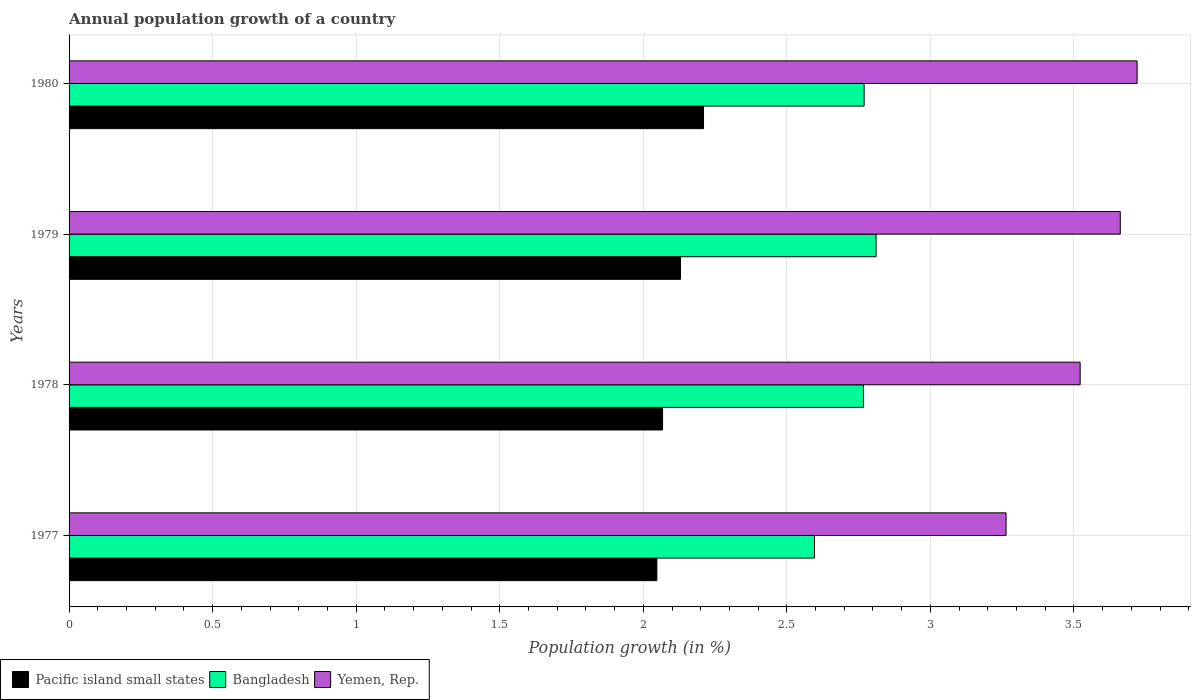How many groups of bars are there?
Offer a terse response. 4. What is the label of the 3rd group of bars from the top?
Your answer should be very brief. 1978. In how many cases, is the number of bars for a given year not equal to the number of legend labels?
Offer a very short reply. 0. What is the annual population growth in Bangladesh in 1980?
Your response must be concise. 2.77. Across all years, what is the maximum annual population growth in Yemen, Rep.?
Your answer should be very brief. 3.72. Across all years, what is the minimum annual population growth in Bangladesh?
Offer a very short reply. 2.6. What is the total annual population growth in Yemen, Rep. in the graph?
Make the answer very short. 14.17. What is the difference between the annual population growth in Bangladesh in 1977 and that in 1978?
Keep it short and to the point. -0.17. What is the difference between the annual population growth in Bangladesh in 1979 and the annual population growth in Pacific island small states in 1978?
Provide a short and direct response. 0.74. What is the average annual population growth in Pacific island small states per year?
Keep it short and to the point. 2.11. In the year 1980, what is the difference between the annual population growth in Pacific island small states and annual population growth in Bangladesh?
Give a very brief answer. -0.56. What is the ratio of the annual population growth in Bangladesh in 1978 to that in 1980?
Your response must be concise. 1. Is the annual population growth in Bangladesh in 1979 less than that in 1980?
Provide a short and direct response. No. Is the difference between the annual population growth in Pacific island small states in 1977 and 1978 greater than the difference between the annual population growth in Bangladesh in 1977 and 1978?
Keep it short and to the point. Yes. What is the difference between the highest and the second highest annual population growth in Bangladesh?
Your answer should be compact. 0.04. What is the difference between the highest and the lowest annual population growth in Yemen, Rep.?
Keep it short and to the point. 0.46. What does the 3rd bar from the top in 1977 represents?
Make the answer very short. Pacific island small states. What does the 3rd bar from the bottom in 1979 represents?
Your answer should be compact. Yemen, Rep. Is it the case that in every year, the sum of the annual population growth in Yemen, Rep. and annual population growth in Pacific island small states is greater than the annual population growth in Bangladesh?
Your response must be concise. Yes. How many bars are there?
Provide a succinct answer. 12. What is the difference between two consecutive major ticks on the X-axis?
Your answer should be compact. 0.5. Are the values on the major ticks of X-axis written in scientific E-notation?
Your answer should be very brief. No. Does the graph contain any zero values?
Offer a very short reply. No. Does the graph contain grids?
Your answer should be very brief. Yes. Where does the legend appear in the graph?
Make the answer very short. Bottom left. How many legend labels are there?
Your answer should be very brief. 3. What is the title of the graph?
Keep it short and to the point. Annual population growth of a country. What is the label or title of the X-axis?
Your answer should be very brief. Population growth (in %). What is the label or title of the Y-axis?
Provide a short and direct response. Years. What is the Population growth (in %) in Pacific island small states in 1977?
Ensure brevity in your answer.  2.05. What is the Population growth (in %) in Bangladesh in 1977?
Offer a very short reply. 2.6. What is the Population growth (in %) of Yemen, Rep. in 1977?
Your response must be concise. 3.26. What is the Population growth (in %) of Pacific island small states in 1978?
Offer a terse response. 2.07. What is the Population growth (in %) of Bangladesh in 1978?
Give a very brief answer. 2.77. What is the Population growth (in %) in Yemen, Rep. in 1978?
Offer a very short reply. 3.52. What is the Population growth (in %) of Pacific island small states in 1979?
Your answer should be very brief. 2.13. What is the Population growth (in %) in Bangladesh in 1979?
Offer a very short reply. 2.81. What is the Population growth (in %) in Yemen, Rep. in 1979?
Keep it short and to the point. 3.66. What is the Population growth (in %) of Pacific island small states in 1980?
Provide a short and direct response. 2.21. What is the Population growth (in %) in Bangladesh in 1980?
Keep it short and to the point. 2.77. What is the Population growth (in %) in Yemen, Rep. in 1980?
Ensure brevity in your answer.  3.72. Across all years, what is the maximum Population growth (in %) in Pacific island small states?
Your answer should be very brief. 2.21. Across all years, what is the maximum Population growth (in %) of Bangladesh?
Ensure brevity in your answer.  2.81. Across all years, what is the maximum Population growth (in %) of Yemen, Rep.?
Keep it short and to the point. 3.72. Across all years, what is the minimum Population growth (in %) of Pacific island small states?
Ensure brevity in your answer.  2.05. Across all years, what is the minimum Population growth (in %) of Bangladesh?
Keep it short and to the point. 2.6. Across all years, what is the minimum Population growth (in %) of Yemen, Rep.?
Provide a succinct answer. 3.26. What is the total Population growth (in %) in Pacific island small states in the graph?
Provide a succinct answer. 8.45. What is the total Population growth (in %) of Bangladesh in the graph?
Ensure brevity in your answer.  10.94. What is the total Population growth (in %) in Yemen, Rep. in the graph?
Provide a succinct answer. 14.17. What is the difference between the Population growth (in %) of Pacific island small states in 1977 and that in 1978?
Offer a very short reply. -0.02. What is the difference between the Population growth (in %) in Bangladesh in 1977 and that in 1978?
Offer a very short reply. -0.17. What is the difference between the Population growth (in %) in Yemen, Rep. in 1977 and that in 1978?
Your response must be concise. -0.26. What is the difference between the Population growth (in %) in Pacific island small states in 1977 and that in 1979?
Keep it short and to the point. -0.08. What is the difference between the Population growth (in %) in Bangladesh in 1977 and that in 1979?
Your answer should be compact. -0.21. What is the difference between the Population growth (in %) in Yemen, Rep. in 1977 and that in 1979?
Make the answer very short. -0.4. What is the difference between the Population growth (in %) in Pacific island small states in 1977 and that in 1980?
Ensure brevity in your answer.  -0.16. What is the difference between the Population growth (in %) in Bangladesh in 1977 and that in 1980?
Provide a short and direct response. -0.17. What is the difference between the Population growth (in %) of Yemen, Rep. in 1977 and that in 1980?
Your answer should be very brief. -0.46. What is the difference between the Population growth (in %) in Pacific island small states in 1978 and that in 1979?
Provide a succinct answer. -0.06. What is the difference between the Population growth (in %) of Bangladesh in 1978 and that in 1979?
Give a very brief answer. -0.04. What is the difference between the Population growth (in %) of Yemen, Rep. in 1978 and that in 1979?
Offer a terse response. -0.14. What is the difference between the Population growth (in %) of Pacific island small states in 1978 and that in 1980?
Offer a very short reply. -0.14. What is the difference between the Population growth (in %) of Bangladesh in 1978 and that in 1980?
Keep it short and to the point. -0. What is the difference between the Population growth (in %) in Yemen, Rep. in 1978 and that in 1980?
Provide a succinct answer. -0.2. What is the difference between the Population growth (in %) in Pacific island small states in 1979 and that in 1980?
Your response must be concise. -0.08. What is the difference between the Population growth (in %) of Bangladesh in 1979 and that in 1980?
Keep it short and to the point. 0.04. What is the difference between the Population growth (in %) in Yemen, Rep. in 1979 and that in 1980?
Keep it short and to the point. -0.06. What is the difference between the Population growth (in %) in Pacific island small states in 1977 and the Population growth (in %) in Bangladesh in 1978?
Provide a succinct answer. -0.72. What is the difference between the Population growth (in %) of Pacific island small states in 1977 and the Population growth (in %) of Yemen, Rep. in 1978?
Offer a very short reply. -1.47. What is the difference between the Population growth (in %) in Bangladesh in 1977 and the Population growth (in %) in Yemen, Rep. in 1978?
Keep it short and to the point. -0.93. What is the difference between the Population growth (in %) of Pacific island small states in 1977 and the Population growth (in %) of Bangladesh in 1979?
Give a very brief answer. -0.76. What is the difference between the Population growth (in %) of Pacific island small states in 1977 and the Population growth (in %) of Yemen, Rep. in 1979?
Your answer should be very brief. -1.61. What is the difference between the Population growth (in %) in Bangladesh in 1977 and the Population growth (in %) in Yemen, Rep. in 1979?
Your answer should be compact. -1.07. What is the difference between the Population growth (in %) of Pacific island small states in 1977 and the Population growth (in %) of Bangladesh in 1980?
Give a very brief answer. -0.72. What is the difference between the Population growth (in %) of Pacific island small states in 1977 and the Population growth (in %) of Yemen, Rep. in 1980?
Provide a succinct answer. -1.67. What is the difference between the Population growth (in %) in Bangladesh in 1977 and the Population growth (in %) in Yemen, Rep. in 1980?
Keep it short and to the point. -1.12. What is the difference between the Population growth (in %) in Pacific island small states in 1978 and the Population growth (in %) in Bangladesh in 1979?
Offer a terse response. -0.74. What is the difference between the Population growth (in %) in Pacific island small states in 1978 and the Population growth (in %) in Yemen, Rep. in 1979?
Give a very brief answer. -1.59. What is the difference between the Population growth (in %) in Bangladesh in 1978 and the Population growth (in %) in Yemen, Rep. in 1979?
Provide a succinct answer. -0.89. What is the difference between the Population growth (in %) of Pacific island small states in 1978 and the Population growth (in %) of Bangladesh in 1980?
Make the answer very short. -0.7. What is the difference between the Population growth (in %) in Pacific island small states in 1978 and the Population growth (in %) in Yemen, Rep. in 1980?
Offer a terse response. -1.65. What is the difference between the Population growth (in %) of Bangladesh in 1978 and the Population growth (in %) of Yemen, Rep. in 1980?
Your answer should be compact. -0.95. What is the difference between the Population growth (in %) in Pacific island small states in 1979 and the Population growth (in %) in Bangladesh in 1980?
Provide a short and direct response. -0.64. What is the difference between the Population growth (in %) in Pacific island small states in 1979 and the Population growth (in %) in Yemen, Rep. in 1980?
Provide a short and direct response. -1.59. What is the difference between the Population growth (in %) of Bangladesh in 1979 and the Population growth (in %) of Yemen, Rep. in 1980?
Your answer should be very brief. -0.91. What is the average Population growth (in %) in Pacific island small states per year?
Make the answer very short. 2.11. What is the average Population growth (in %) in Bangladesh per year?
Ensure brevity in your answer.  2.74. What is the average Population growth (in %) in Yemen, Rep. per year?
Give a very brief answer. 3.54. In the year 1977, what is the difference between the Population growth (in %) in Pacific island small states and Population growth (in %) in Bangladesh?
Your answer should be very brief. -0.55. In the year 1977, what is the difference between the Population growth (in %) of Pacific island small states and Population growth (in %) of Yemen, Rep.?
Your answer should be very brief. -1.22. In the year 1977, what is the difference between the Population growth (in %) of Bangladesh and Population growth (in %) of Yemen, Rep.?
Your answer should be compact. -0.67. In the year 1978, what is the difference between the Population growth (in %) of Pacific island small states and Population growth (in %) of Bangladesh?
Give a very brief answer. -0.7. In the year 1978, what is the difference between the Population growth (in %) of Pacific island small states and Population growth (in %) of Yemen, Rep.?
Offer a very short reply. -1.45. In the year 1978, what is the difference between the Population growth (in %) of Bangladesh and Population growth (in %) of Yemen, Rep.?
Your response must be concise. -0.75. In the year 1979, what is the difference between the Population growth (in %) of Pacific island small states and Population growth (in %) of Bangladesh?
Offer a very short reply. -0.68. In the year 1979, what is the difference between the Population growth (in %) of Pacific island small states and Population growth (in %) of Yemen, Rep.?
Make the answer very short. -1.53. In the year 1979, what is the difference between the Population growth (in %) in Bangladesh and Population growth (in %) in Yemen, Rep.?
Give a very brief answer. -0.85. In the year 1980, what is the difference between the Population growth (in %) in Pacific island small states and Population growth (in %) in Bangladesh?
Your answer should be compact. -0.56. In the year 1980, what is the difference between the Population growth (in %) in Pacific island small states and Population growth (in %) in Yemen, Rep.?
Ensure brevity in your answer.  -1.51. In the year 1980, what is the difference between the Population growth (in %) in Bangladesh and Population growth (in %) in Yemen, Rep.?
Make the answer very short. -0.95. What is the ratio of the Population growth (in %) of Pacific island small states in 1977 to that in 1978?
Offer a terse response. 0.99. What is the ratio of the Population growth (in %) of Bangladesh in 1977 to that in 1978?
Provide a short and direct response. 0.94. What is the ratio of the Population growth (in %) of Yemen, Rep. in 1977 to that in 1978?
Provide a succinct answer. 0.93. What is the ratio of the Population growth (in %) in Pacific island small states in 1977 to that in 1979?
Offer a terse response. 0.96. What is the ratio of the Population growth (in %) in Bangladesh in 1977 to that in 1979?
Ensure brevity in your answer.  0.92. What is the ratio of the Population growth (in %) in Yemen, Rep. in 1977 to that in 1979?
Provide a succinct answer. 0.89. What is the ratio of the Population growth (in %) in Pacific island small states in 1977 to that in 1980?
Offer a terse response. 0.93. What is the ratio of the Population growth (in %) of Bangladesh in 1977 to that in 1980?
Offer a very short reply. 0.94. What is the ratio of the Population growth (in %) of Yemen, Rep. in 1977 to that in 1980?
Your answer should be compact. 0.88. What is the ratio of the Population growth (in %) of Pacific island small states in 1978 to that in 1979?
Give a very brief answer. 0.97. What is the ratio of the Population growth (in %) in Bangladesh in 1978 to that in 1979?
Make the answer very short. 0.98. What is the ratio of the Population growth (in %) in Yemen, Rep. in 1978 to that in 1979?
Give a very brief answer. 0.96. What is the ratio of the Population growth (in %) of Pacific island small states in 1978 to that in 1980?
Offer a terse response. 0.94. What is the ratio of the Population growth (in %) of Yemen, Rep. in 1978 to that in 1980?
Make the answer very short. 0.95. What is the ratio of the Population growth (in %) of Pacific island small states in 1979 to that in 1980?
Your answer should be very brief. 0.96. What is the ratio of the Population growth (in %) of Bangladesh in 1979 to that in 1980?
Your response must be concise. 1.01. What is the ratio of the Population growth (in %) of Yemen, Rep. in 1979 to that in 1980?
Your answer should be compact. 0.98. What is the difference between the highest and the second highest Population growth (in %) in Pacific island small states?
Give a very brief answer. 0.08. What is the difference between the highest and the second highest Population growth (in %) in Bangladesh?
Ensure brevity in your answer.  0.04. What is the difference between the highest and the second highest Population growth (in %) in Yemen, Rep.?
Make the answer very short. 0.06. What is the difference between the highest and the lowest Population growth (in %) in Pacific island small states?
Your response must be concise. 0.16. What is the difference between the highest and the lowest Population growth (in %) in Bangladesh?
Your response must be concise. 0.21. What is the difference between the highest and the lowest Population growth (in %) of Yemen, Rep.?
Your answer should be compact. 0.46. 